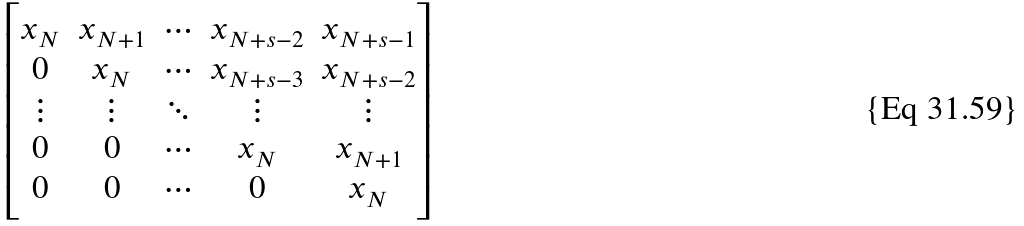Convert formula to latex. <formula><loc_0><loc_0><loc_500><loc_500>\begin{bmatrix} x _ { N } & x _ { N + 1 } & \cdots & x _ { N + s - 2 } & x _ { N + s - 1 } \\ 0 & x _ { N } & \cdots & x _ { N + s - 3 } & x _ { N + s - 2 } \\ \vdots & \vdots & \ddots & \vdots & \vdots \\ 0 & 0 & \cdots & x _ { N } & x _ { N + 1 } \\ 0 & 0 & \cdots & 0 & x _ { N } \end{bmatrix}</formula> 